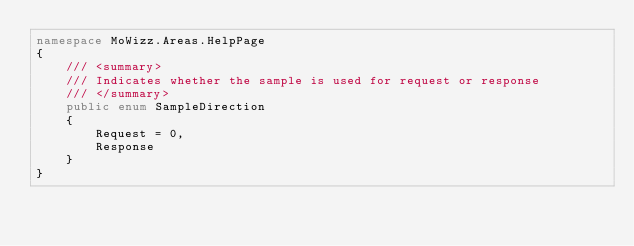Convert code to text. <code><loc_0><loc_0><loc_500><loc_500><_C#_>namespace MoWizz.Areas.HelpPage
{
    /// <summary>
    /// Indicates whether the sample is used for request or response
    /// </summary>
    public enum SampleDirection
    {
        Request = 0,
        Response
    }
}</code> 